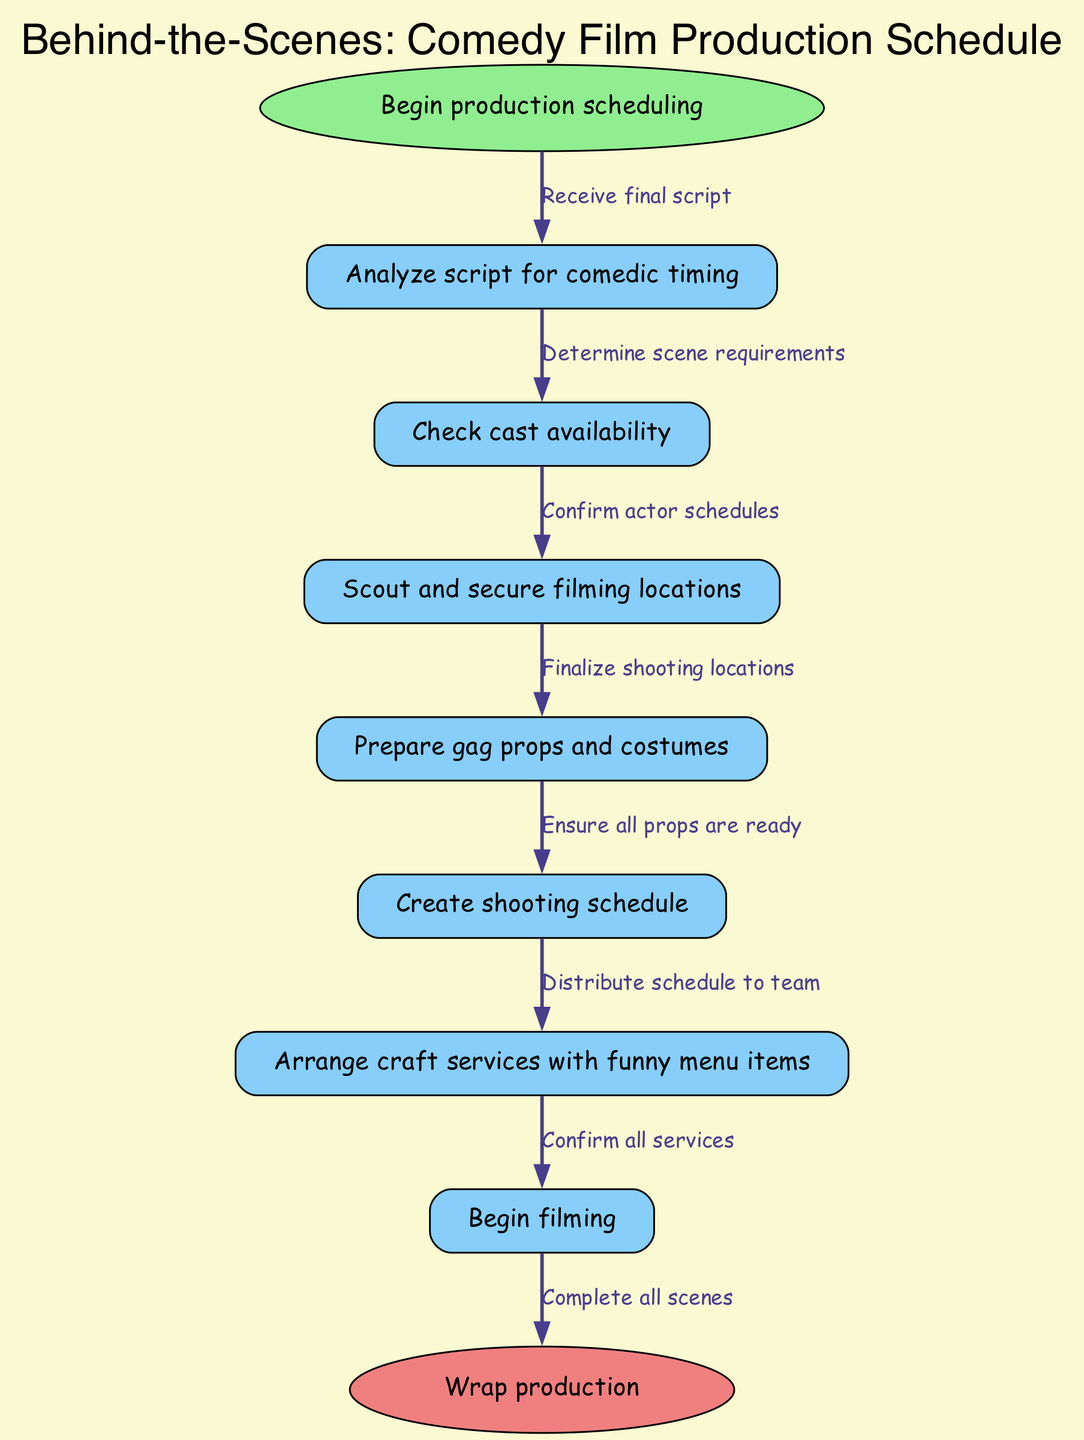What is the first step in the production scheduling? The diagram indicates that the first step in the production scheduling is to "Begin production scheduling." This is represented as the starting node from which all other tasks flow.
Answer: Begin production scheduling How many nodes are there in total? By counting the distinct nodes listed in the diagram, we find there are 9 nodes: Begin production scheduling, Analyze script for comedic timing, Check cast availability, Scout and secure filming locations, Prepare gag props and costumes, Create shooting schedule, Arrange craft services with funny menu items, Begin filming, and Wrap production.
Answer: 9 What follows after analyzing the script? According to the flowchart, after "Analyze script for comedic timing," the next step is to "Check cast availability." This shows the direct relationship between these two nodes in the production process.
Answer: Check cast availability What is the purpose of the node "Arrange craft services with funny menu items"? The role of this node is to make arrangements for catering, specifically highlighting that the menu should have a humorous element, aligning with the comedic theme of the film being produced.
Answer: To arrange catering with funny menu items Which node is the last step before wrapping production? The final step before "Wrap production" is the "Begin filming" node. This indicates that filming must be completed before the production can conclude.
Answer: Begin filming How does one ensure all props are ready? According to the flowchart, the preparation of all props is ensured after the "Finalize shooting locations" step, specifically before creating the shooting schedule. This implies that having the locations finalized is a prerequisite for props readiness.
Answer: Finalize shooting locations What node has a humorous element associated with it? The node titled "Arrange craft services with funny menu items" directly communicates the humorous aspect in its description, which is a unique feature in the context of film production scheduling.
Answer: Arrange craft services with funny menu items Which task confirms actor schedules? The task that confirms actor schedules is encapsulated in the node "Check cast availability." This key action is crucial for coordinating filming dates.
Answer: Check cast availability 